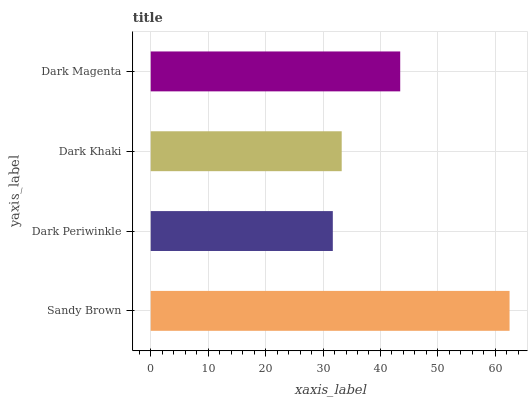Is Dark Periwinkle the minimum?
Answer yes or no. Yes. Is Sandy Brown the maximum?
Answer yes or no. Yes. Is Dark Khaki the minimum?
Answer yes or no. No. Is Dark Khaki the maximum?
Answer yes or no. No. Is Dark Khaki greater than Dark Periwinkle?
Answer yes or no. Yes. Is Dark Periwinkle less than Dark Khaki?
Answer yes or no. Yes. Is Dark Periwinkle greater than Dark Khaki?
Answer yes or no. No. Is Dark Khaki less than Dark Periwinkle?
Answer yes or no. No. Is Dark Magenta the high median?
Answer yes or no. Yes. Is Dark Khaki the low median?
Answer yes or no. Yes. Is Dark Periwinkle the high median?
Answer yes or no. No. Is Dark Magenta the low median?
Answer yes or no. No. 